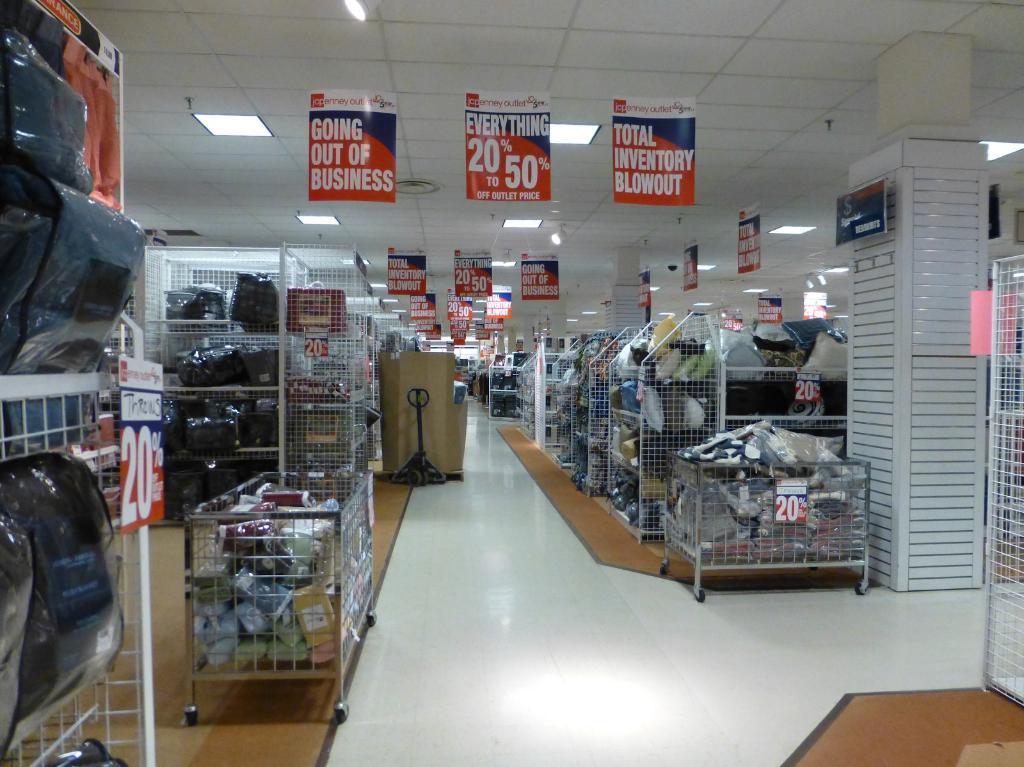Can you describe this image briefly? The picture is taken in a store. In this picture we can see is racks, bags, machine, boxes, floor and various objects. At the top there are banners, light and ceiling. 